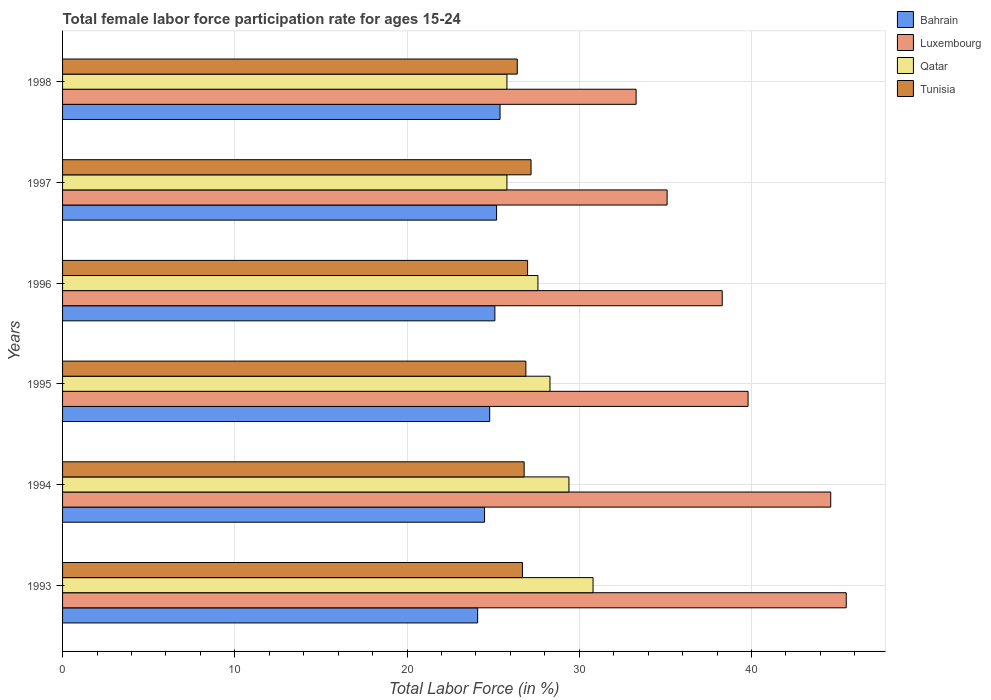How many groups of bars are there?
Keep it short and to the point. 6. How many bars are there on the 6th tick from the top?
Provide a succinct answer. 4. How many bars are there on the 1st tick from the bottom?
Your answer should be compact. 4. What is the label of the 6th group of bars from the top?
Your answer should be very brief. 1993. In how many cases, is the number of bars for a given year not equal to the number of legend labels?
Offer a very short reply. 0. What is the female labor force participation rate in Tunisia in 1998?
Your answer should be very brief. 26.4. Across all years, what is the maximum female labor force participation rate in Qatar?
Your response must be concise. 30.8. Across all years, what is the minimum female labor force participation rate in Luxembourg?
Your response must be concise. 33.3. In which year was the female labor force participation rate in Luxembourg minimum?
Give a very brief answer. 1998. What is the total female labor force participation rate in Luxembourg in the graph?
Keep it short and to the point. 236.6. What is the difference between the female labor force participation rate in Bahrain in 1995 and that in 1998?
Ensure brevity in your answer.  -0.6. What is the difference between the female labor force participation rate in Luxembourg in 1998 and the female labor force participation rate in Tunisia in 1997?
Make the answer very short. 6.1. What is the average female labor force participation rate in Luxembourg per year?
Offer a terse response. 39.43. What is the ratio of the female labor force participation rate in Tunisia in 1995 to that in 1997?
Ensure brevity in your answer.  0.99. Is the difference between the female labor force participation rate in Tunisia in 1994 and 1997 greater than the difference between the female labor force participation rate in Bahrain in 1994 and 1997?
Your response must be concise. Yes. What is the difference between the highest and the second highest female labor force participation rate in Luxembourg?
Give a very brief answer. 0.9. What is the difference between the highest and the lowest female labor force participation rate in Luxembourg?
Provide a succinct answer. 12.2. Is the sum of the female labor force participation rate in Qatar in 1993 and 1994 greater than the maximum female labor force participation rate in Tunisia across all years?
Offer a terse response. Yes. Is it the case that in every year, the sum of the female labor force participation rate in Tunisia and female labor force participation rate in Qatar is greater than the sum of female labor force participation rate in Bahrain and female labor force participation rate in Luxembourg?
Provide a short and direct response. Yes. What does the 1st bar from the top in 1994 represents?
Your response must be concise. Tunisia. What does the 2nd bar from the bottom in 1995 represents?
Your response must be concise. Luxembourg. Does the graph contain any zero values?
Make the answer very short. No. Does the graph contain grids?
Make the answer very short. Yes. Where does the legend appear in the graph?
Provide a short and direct response. Top right. How are the legend labels stacked?
Provide a short and direct response. Vertical. What is the title of the graph?
Provide a short and direct response. Total female labor force participation rate for ages 15-24. What is the Total Labor Force (in %) in Bahrain in 1993?
Make the answer very short. 24.1. What is the Total Labor Force (in %) in Luxembourg in 1993?
Provide a succinct answer. 45.5. What is the Total Labor Force (in %) in Qatar in 1993?
Your answer should be compact. 30.8. What is the Total Labor Force (in %) of Tunisia in 1993?
Your answer should be very brief. 26.7. What is the Total Labor Force (in %) of Luxembourg in 1994?
Your answer should be very brief. 44.6. What is the Total Labor Force (in %) in Qatar in 1994?
Give a very brief answer. 29.4. What is the Total Labor Force (in %) in Tunisia in 1994?
Offer a very short reply. 26.8. What is the Total Labor Force (in %) of Bahrain in 1995?
Offer a terse response. 24.8. What is the Total Labor Force (in %) of Luxembourg in 1995?
Your response must be concise. 39.8. What is the Total Labor Force (in %) of Qatar in 1995?
Give a very brief answer. 28.3. What is the Total Labor Force (in %) in Tunisia in 1995?
Provide a succinct answer. 26.9. What is the Total Labor Force (in %) in Bahrain in 1996?
Your answer should be very brief. 25.1. What is the Total Labor Force (in %) in Luxembourg in 1996?
Keep it short and to the point. 38.3. What is the Total Labor Force (in %) in Qatar in 1996?
Your answer should be very brief. 27.6. What is the Total Labor Force (in %) in Bahrain in 1997?
Give a very brief answer. 25.2. What is the Total Labor Force (in %) in Luxembourg in 1997?
Ensure brevity in your answer.  35.1. What is the Total Labor Force (in %) of Qatar in 1997?
Provide a succinct answer. 25.8. What is the Total Labor Force (in %) of Tunisia in 1997?
Keep it short and to the point. 27.2. What is the Total Labor Force (in %) of Bahrain in 1998?
Your answer should be very brief. 25.4. What is the Total Labor Force (in %) of Luxembourg in 1998?
Offer a very short reply. 33.3. What is the Total Labor Force (in %) of Qatar in 1998?
Make the answer very short. 25.8. What is the Total Labor Force (in %) of Tunisia in 1998?
Offer a very short reply. 26.4. Across all years, what is the maximum Total Labor Force (in %) in Bahrain?
Provide a succinct answer. 25.4. Across all years, what is the maximum Total Labor Force (in %) in Luxembourg?
Provide a succinct answer. 45.5. Across all years, what is the maximum Total Labor Force (in %) in Qatar?
Offer a very short reply. 30.8. Across all years, what is the maximum Total Labor Force (in %) of Tunisia?
Offer a very short reply. 27.2. Across all years, what is the minimum Total Labor Force (in %) in Bahrain?
Provide a succinct answer. 24.1. Across all years, what is the minimum Total Labor Force (in %) in Luxembourg?
Offer a terse response. 33.3. Across all years, what is the minimum Total Labor Force (in %) in Qatar?
Your answer should be very brief. 25.8. Across all years, what is the minimum Total Labor Force (in %) in Tunisia?
Offer a terse response. 26.4. What is the total Total Labor Force (in %) in Bahrain in the graph?
Provide a succinct answer. 149.1. What is the total Total Labor Force (in %) of Luxembourg in the graph?
Provide a short and direct response. 236.6. What is the total Total Labor Force (in %) in Qatar in the graph?
Provide a short and direct response. 167.7. What is the total Total Labor Force (in %) of Tunisia in the graph?
Provide a succinct answer. 161. What is the difference between the Total Labor Force (in %) in Tunisia in 1993 and that in 1994?
Your answer should be very brief. -0.1. What is the difference between the Total Labor Force (in %) of Bahrain in 1993 and that in 1995?
Your response must be concise. -0.7. What is the difference between the Total Labor Force (in %) in Luxembourg in 1993 and that in 1995?
Your response must be concise. 5.7. What is the difference between the Total Labor Force (in %) in Bahrain in 1993 and that in 1996?
Keep it short and to the point. -1. What is the difference between the Total Labor Force (in %) in Qatar in 1993 and that in 1996?
Your answer should be compact. 3.2. What is the difference between the Total Labor Force (in %) in Tunisia in 1993 and that in 1996?
Provide a succinct answer. -0.3. What is the difference between the Total Labor Force (in %) in Bahrain in 1993 and that in 1997?
Offer a terse response. -1.1. What is the difference between the Total Labor Force (in %) in Luxembourg in 1993 and that in 1997?
Offer a terse response. 10.4. What is the difference between the Total Labor Force (in %) in Tunisia in 1993 and that in 1997?
Provide a succinct answer. -0.5. What is the difference between the Total Labor Force (in %) in Luxembourg in 1993 and that in 1998?
Your answer should be very brief. 12.2. What is the difference between the Total Labor Force (in %) of Qatar in 1993 and that in 1998?
Your answer should be compact. 5. What is the difference between the Total Labor Force (in %) of Bahrain in 1994 and that in 1995?
Offer a very short reply. -0.3. What is the difference between the Total Labor Force (in %) in Luxembourg in 1994 and that in 1995?
Your answer should be compact. 4.8. What is the difference between the Total Labor Force (in %) in Qatar in 1994 and that in 1995?
Your response must be concise. 1.1. What is the difference between the Total Labor Force (in %) in Tunisia in 1994 and that in 1995?
Give a very brief answer. -0.1. What is the difference between the Total Labor Force (in %) of Bahrain in 1994 and that in 1996?
Give a very brief answer. -0.6. What is the difference between the Total Labor Force (in %) of Luxembourg in 1994 and that in 1996?
Keep it short and to the point. 6.3. What is the difference between the Total Labor Force (in %) of Qatar in 1994 and that in 1996?
Keep it short and to the point. 1.8. What is the difference between the Total Labor Force (in %) in Bahrain in 1994 and that in 1997?
Ensure brevity in your answer.  -0.7. What is the difference between the Total Labor Force (in %) in Luxembourg in 1994 and that in 1997?
Offer a very short reply. 9.5. What is the difference between the Total Labor Force (in %) of Bahrain in 1994 and that in 1998?
Provide a succinct answer. -0.9. What is the difference between the Total Labor Force (in %) in Qatar in 1994 and that in 1998?
Make the answer very short. 3.6. What is the difference between the Total Labor Force (in %) in Tunisia in 1994 and that in 1998?
Your response must be concise. 0.4. What is the difference between the Total Labor Force (in %) of Qatar in 1995 and that in 1997?
Provide a succinct answer. 2.5. What is the difference between the Total Labor Force (in %) of Tunisia in 1995 and that in 1997?
Offer a very short reply. -0.3. What is the difference between the Total Labor Force (in %) in Bahrain in 1995 and that in 1998?
Offer a terse response. -0.6. What is the difference between the Total Labor Force (in %) of Luxembourg in 1995 and that in 1998?
Make the answer very short. 6.5. What is the difference between the Total Labor Force (in %) in Qatar in 1995 and that in 1998?
Make the answer very short. 2.5. What is the difference between the Total Labor Force (in %) in Bahrain in 1996 and that in 1997?
Provide a short and direct response. -0.1. What is the difference between the Total Labor Force (in %) of Qatar in 1996 and that in 1997?
Provide a short and direct response. 1.8. What is the difference between the Total Labor Force (in %) of Bahrain in 1996 and that in 1998?
Make the answer very short. -0.3. What is the difference between the Total Labor Force (in %) in Luxembourg in 1996 and that in 1998?
Offer a terse response. 5. What is the difference between the Total Labor Force (in %) in Qatar in 1996 and that in 1998?
Offer a very short reply. 1.8. What is the difference between the Total Labor Force (in %) of Luxembourg in 1997 and that in 1998?
Provide a succinct answer. 1.8. What is the difference between the Total Labor Force (in %) in Qatar in 1997 and that in 1998?
Provide a succinct answer. 0. What is the difference between the Total Labor Force (in %) in Tunisia in 1997 and that in 1998?
Your response must be concise. 0.8. What is the difference between the Total Labor Force (in %) in Bahrain in 1993 and the Total Labor Force (in %) in Luxembourg in 1994?
Offer a very short reply. -20.5. What is the difference between the Total Labor Force (in %) of Bahrain in 1993 and the Total Labor Force (in %) of Qatar in 1994?
Your answer should be compact. -5.3. What is the difference between the Total Labor Force (in %) in Luxembourg in 1993 and the Total Labor Force (in %) in Qatar in 1994?
Your response must be concise. 16.1. What is the difference between the Total Labor Force (in %) in Qatar in 1993 and the Total Labor Force (in %) in Tunisia in 1994?
Your answer should be compact. 4. What is the difference between the Total Labor Force (in %) in Bahrain in 1993 and the Total Labor Force (in %) in Luxembourg in 1995?
Make the answer very short. -15.7. What is the difference between the Total Labor Force (in %) in Bahrain in 1993 and the Total Labor Force (in %) in Qatar in 1995?
Provide a succinct answer. -4.2. What is the difference between the Total Labor Force (in %) of Luxembourg in 1993 and the Total Labor Force (in %) of Tunisia in 1995?
Your response must be concise. 18.6. What is the difference between the Total Labor Force (in %) in Bahrain in 1993 and the Total Labor Force (in %) in Luxembourg in 1996?
Provide a short and direct response. -14.2. What is the difference between the Total Labor Force (in %) of Bahrain in 1993 and the Total Labor Force (in %) of Qatar in 1996?
Give a very brief answer. -3.5. What is the difference between the Total Labor Force (in %) in Luxembourg in 1993 and the Total Labor Force (in %) in Qatar in 1996?
Provide a short and direct response. 17.9. What is the difference between the Total Labor Force (in %) in Luxembourg in 1993 and the Total Labor Force (in %) in Tunisia in 1996?
Give a very brief answer. 18.5. What is the difference between the Total Labor Force (in %) in Bahrain in 1993 and the Total Labor Force (in %) in Qatar in 1997?
Provide a short and direct response. -1.7. What is the difference between the Total Labor Force (in %) in Bahrain in 1993 and the Total Labor Force (in %) in Luxembourg in 1998?
Your answer should be compact. -9.2. What is the difference between the Total Labor Force (in %) of Bahrain in 1993 and the Total Labor Force (in %) of Tunisia in 1998?
Your answer should be very brief. -2.3. What is the difference between the Total Labor Force (in %) of Luxembourg in 1993 and the Total Labor Force (in %) of Tunisia in 1998?
Provide a succinct answer. 19.1. What is the difference between the Total Labor Force (in %) in Bahrain in 1994 and the Total Labor Force (in %) in Luxembourg in 1995?
Your answer should be very brief. -15.3. What is the difference between the Total Labor Force (in %) in Luxembourg in 1994 and the Total Labor Force (in %) in Qatar in 1995?
Offer a terse response. 16.3. What is the difference between the Total Labor Force (in %) in Bahrain in 1994 and the Total Labor Force (in %) in Qatar in 1996?
Ensure brevity in your answer.  -3.1. What is the difference between the Total Labor Force (in %) of Luxembourg in 1994 and the Total Labor Force (in %) of Qatar in 1996?
Provide a succinct answer. 17. What is the difference between the Total Labor Force (in %) in Luxembourg in 1994 and the Total Labor Force (in %) in Tunisia in 1996?
Your response must be concise. 17.6. What is the difference between the Total Labor Force (in %) in Luxembourg in 1994 and the Total Labor Force (in %) in Qatar in 1997?
Make the answer very short. 18.8. What is the difference between the Total Labor Force (in %) in Luxembourg in 1994 and the Total Labor Force (in %) in Tunisia in 1997?
Make the answer very short. 17.4. What is the difference between the Total Labor Force (in %) in Bahrain in 1994 and the Total Labor Force (in %) in Luxembourg in 1998?
Your response must be concise. -8.8. What is the difference between the Total Labor Force (in %) of Bahrain in 1995 and the Total Labor Force (in %) of Luxembourg in 1996?
Keep it short and to the point. -13.5. What is the difference between the Total Labor Force (in %) in Luxembourg in 1995 and the Total Labor Force (in %) in Tunisia in 1996?
Your answer should be very brief. 12.8. What is the difference between the Total Labor Force (in %) in Qatar in 1995 and the Total Labor Force (in %) in Tunisia in 1996?
Ensure brevity in your answer.  1.3. What is the difference between the Total Labor Force (in %) of Bahrain in 1995 and the Total Labor Force (in %) of Luxembourg in 1997?
Ensure brevity in your answer.  -10.3. What is the difference between the Total Labor Force (in %) of Bahrain in 1995 and the Total Labor Force (in %) of Qatar in 1997?
Provide a succinct answer. -1. What is the difference between the Total Labor Force (in %) in Bahrain in 1995 and the Total Labor Force (in %) in Tunisia in 1997?
Offer a terse response. -2.4. What is the difference between the Total Labor Force (in %) in Luxembourg in 1995 and the Total Labor Force (in %) in Qatar in 1997?
Make the answer very short. 14. What is the difference between the Total Labor Force (in %) of Luxembourg in 1995 and the Total Labor Force (in %) of Tunisia in 1997?
Offer a terse response. 12.6. What is the difference between the Total Labor Force (in %) of Qatar in 1995 and the Total Labor Force (in %) of Tunisia in 1997?
Offer a terse response. 1.1. What is the difference between the Total Labor Force (in %) in Bahrain in 1995 and the Total Labor Force (in %) in Tunisia in 1998?
Your response must be concise. -1.6. What is the difference between the Total Labor Force (in %) in Bahrain in 1996 and the Total Labor Force (in %) in Luxembourg in 1997?
Your answer should be compact. -10. What is the difference between the Total Labor Force (in %) in Luxembourg in 1996 and the Total Labor Force (in %) in Tunisia in 1997?
Keep it short and to the point. 11.1. What is the difference between the Total Labor Force (in %) of Bahrain in 1996 and the Total Labor Force (in %) of Tunisia in 1998?
Ensure brevity in your answer.  -1.3. What is the difference between the Total Labor Force (in %) in Luxembourg in 1996 and the Total Labor Force (in %) in Qatar in 1998?
Offer a very short reply. 12.5. What is the difference between the Total Labor Force (in %) in Bahrain in 1997 and the Total Labor Force (in %) in Luxembourg in 1998?
Offer a very short reply. -8.1. What is the difference between the Total Labor Force (in %) of Bahrain in 1997 and the Total Labor Force (in %) of Qatar in 1998?
Keep it short and to the point. -0.6. What is the difference between the Total Labor Force (in %) in Luxembourg in 1997 and the Total Labor Force (in %) in Qatar in 1998?
Your answer should be very brief. 9.3. What is the average Total Labor Force (in %) of Bahrain per year?
Offer a very short reply. 24.85. What is the average Total Labor Force (in %) in Luxembourg per year?
Ensure brevity in your answer.  39.43. What is the average Total Labor Force (in %) in Qatar per year?
Make the answer very short. 27.95. What is the average Total Labor Force (in %) in Tunisia per year?
Offer a very short reply. 26.83. In the year 1993, what is the difference between the Total Labor Force (in %) in Bahrain and Total Labor Force (in %) in Luxembourg?
Give a very brief answer. -21.4. In the year 1993, what is the difference between the Total Labor Force (in %) of Bahrain and Total Labor Force (in %) of Tunisia?
Keep it short and to the point. -2.6. In the year 1993, what is the difference between the Total Labor Force (in %) in Luxembourg and Total Labor Force (in %) in Qatar?
Your answer should be very brief. 14.7. In the year 1994, what is the difference between the Total Labor Force (in %) in Bahrain and Total Labor Force (in %) in Luxembourg?
Your response must be concise. -20.1. In the year 1994, what is the difference between the Total Labor Force (in %) of Bahrain and Total Labor Force (in %) of Qatar?
Make the answer very short. -4.9. In the year 1994, what is the difference between the Total Labor Force (in %) of Luxembourg and Total Labor Force (in %) of Tunisia?
Ensure brevity in your answer.  17.8. In the year 1995, what is the difference between the Total Labor Force (in %) of Bahrain and Total Labor Force (in %) of Luxembourg?
Your response must be concise. -15. In the year 1995, what is the difference between the Total Labor Force (in %) in Bahrain and Total Labor Force (in %) in Qatar?
Your answer should be compact. -3.5. In the year 1995, what is the difference between the Total Labor Force (in %) in Bahrain and Total Labor Force (in %) in Tunisia?
Keep it short and to the point. -2.1. In the year 1995, what is the difference between the Total Labor Force (in %) of Luxembourg and Total Labor Force (in %) of Qatar?
Offer a terse response. 11.5. In the year 1995, what is the difference between the Total Labor Force (in %) in Luxembourg and Total Labor Force (in %) in Tunisia?
Make the answer very short. 12.9. In the year 1995, what is the difference between the Total Labor Force (in %) in Qatar and Total Labor Force (in %) in Tunisia?
Ensure brevity in your answer.  1.4. In the year 1996, what is the difference between the Total Labor Force (in %) of Bahrain and Total Labor Force (in %) of Qatar?
Give a very brief answer. -2.5. In the year 1997, what is the difference between the Total Labor Force (in %) of Luxembourg and Total Labor Force (in %) of Tunisia?
Your response must be concise. 7.9. What is the ratio of the Total Labor Force (in %) in Bahrain in 1993 to that in 1994?
Your answer should be compact. 0.98. What is the ratio of the Total Labor Force (in %) in Luxembourg in 1993 to that in 1994?
Keep it short and to the point. 1.02. What is the ratio of the Total Labor Force (in %) of Qatar in 1993 to that in 1994?
Your answer should be compact. 1.05. What is the ratio of the Total Labor Force (in %) in Tunisia in 1993 to that in 1994?
Offer a terse response. 1. What is the ratio of the Total Labor Force (in %) in Bahrain in 1993 to that in 1995?
Offer a terse response. 0.97. What is the ratio of the Total Labor Force (in %) of Luxembourg in 1993 to that in 1995?
Give a very brief answer. 1.14. What is the ratio of the Total Labor Force (in %) in Qatar in 1993 to that in 1995?
Your answer should be compact. 1.09. What is the ratio of the Total Labor Force (in %) in Bahrain in 1993 to that in 1996?
Offer a terse response. 0.96. What is the ratio of the Total Labor Force (in %) in Luxembourg in 1993 to that in 1996?
Keep it short and to the point. 1.19. What is the ratio of the Total Labor Force (in %) in Qatar in 1993 to that in 1996?
Ensure brevity in your answer.  1.12. What is the ratio of the Total Labor Force (in %) in Tunisia in 1993 to that in 1996?
Provide a succinct answer. 0.99. What is the ratio of the Total Labor Force (in %) of Bahrain in 1993 to that in 1997?
Offer a terse response. 0.96. What is the ratio of the Total Labor Force (in %) of Luxembourg in 1993 to that in 1997?
Provide a short and direct response. 1.3. What is the ratio of the Total Labor Force (in %) in Qatar in 1993 to that in 1997?
Keep it short and to the point. 1.19. What is the ratio of the Total Labor Force (in %) of Tunisia in 1993 to that in 1997?
Your response must be concise. 0.98. What is the ratio of the Total Labor Force (in %) in Bahrain in 1993 to that in 1998?
Ensure brevity in your answer.  0.95. What is the ratio of the Total Labor Force (in %) of Luxembourg in 1993 to that in 1998?
Provide a short and direct response. 1.37. What is the ratio of the Total Labor Force (in %) in Qatar in 1993 to that in 1998?
Provide a succinct answer. 1.19. What is the ratio of the Total Labor Force (in %) of Tunisia in 1993 to that in 1998?
Give a very brief answer. 1.01. What is the ratio of the Total Labor Force (in %) in Bahrain in 1994 to that in 1995?
Give a very brief answer. 0.99. What is the ratio of the Total Labor Force (in %) in Luxembourg in 1994 to that in 1995?
Offer a terse response. 1.12. What is the ratio of the Total Labor Force (in %) of Qatar in 1994 to that in 1995?
Ensure brevity in your answer.  1.04. What is the ratio of the Total Labor Force (in %) in Tunisia in 1994 to that in 1995?
Provide a short and direct response. 1. What is the ratio of the Total Labor Force (in %) in Bahrain in 1994 to that in 1996?
Provide a short and direct response. 0.98. What is the ratio of the Total Labor Force (in %) of Luxembourg in 1994 to that in 1996?
Keep it short and to the point. 1.16. What is the ratio of the Total Labor Force (in %) of Qatar in 1994 to that in 1996?
Offer a terse response. 1.07. What is the ratio of the Total Labor Force (in %) of Bahrain in 1994 to that in 1997?
Provide a succinct answer. 0.97. What is the ratio of the Total Labor Force (in %) of Luxembourg in 1994 to that in 1997?
Your answer should be compact. 1.27. What is the ratio of the Total Labor Force (in %) in Qatar in 1994 to that in 1997?
Keep it short and to the point. 1.14. What is the ratio of the Total Labor Force (in %) in Bahrain in 1994 to that in 1998?
Your answer should be compact. 0.96. What is the ratio of the Total Labor Force (in %) of Luxembourg in 1994 to that in 1998?
Offer a terse response. 1.34. What is the ratio of the Total Labor Force (in %) of Qatar in 1994 to that in 1998?
Offer a terse response. 1.14. What is the ratio of the Total Labor Force (in %) of Tunisia in 1994 to that in 1998?
Keep it short and to the point. 1.02. What is the ratio of the Total Labor Force (in %) in Bahrain in 1995 to that in 1996?
Offer a very short reply. 0.99. What is the ratio of the Total Labor Force (in %) in Luxembourg in 1995 to that in 1996?
Offer a very short reply. 1.04. What is the ratio of the Total Labor Force (in %) of Qatar in 1995 to that in 1996?
Provide a succinct answer. 1.03. What is the ratio of the Total Labor Force (in %) in Bahrain in 1995 to that in 1997?
Your answer should be compact. 0.98. What is the ratio of the Total Labor Force (in %) in Luxembourg in 1995 to that in 1997?
Your answer should be very brief. 1.13. What is the ratio of the Total Labor Force (in %) in Qatar in 1995 to that in 1997?
Ensure brevity in your answer.  1.1. What is the ratio of the Total Labor Force (in %) in Tunisia in 1995 to that in 1997?
Your response must be concise. 0.99. What is the ratio of the Total Labor Force (in %) of Bahrain in 1995 to that in 1998?
Offer a very short reply. 0.98. What is the ratio of the Total Labor Force (in %) in Luxembourg in 1995 to that in 1998?
Offer a very short reply. 1.2. What is the ratio of the Total Labor Force (in %) in Qatar in 1995 to that in 1998?
Offer a very short reply. 1.1. What is the ratio of the Total Labor Force (in %) of Tunisia in 1995 to that in 1998?
Ensure brevity in your answer.  1.02. What is the ratio of the Total Labor Force (in %) in Bahrain in 1996 to that in 1997?
Your answer should be compact. 1. What is the ratio of the Total Labor Force (in %) in Luxembourg in 1996 to that in 1997?
Give a very brief answer. 1.09. What is the ratio of the Total Labor Force (in %) in Qatar in 1996 to that in 1997?
Provide a short and direct response. 1.07. What is the ratio of the Total Labor Force (in %) of Bahrain in 1996 to that in 1998?
Your answer should be very brief. 0.99. What is the ratio of the Total Labor Force (in %) in Luxembourg in 1996 to that in 1998?
Provide a short and direct response. 1.15. What is the ratio of the Total Labor Force (in %) of Qatar in 1996 to that in 1998?
Your answer should be compact. 1.07. What is the ratio of the Total Labor Force (in %) of Tunisia in 1996 to that in 1998?
Keep it short and to the point. 1.02. What is the ratio of the Total Labor Force (in %) of Luxembourg in 1997 to that in 1998?
Provide a short and direct response. 1.05. What is the ratio of the Total Labor Force (in %) in Qatar in 1997 to that in 1998?
Give a very brief answer. 1. What is the ratio of the Total Labor Force (in %) of Tunisia in 1997 to that in 1998?
Offer a very short reply. 1.03. What is the difference between the highest and the second highest Total Labor Force (in %) in Luxembourg?
Give a very brief answer. 0.9. What is the difference between the highest and the second highest Total Labor Force (in %) of Qatar?
Keep it short and to the point. 1.4. 